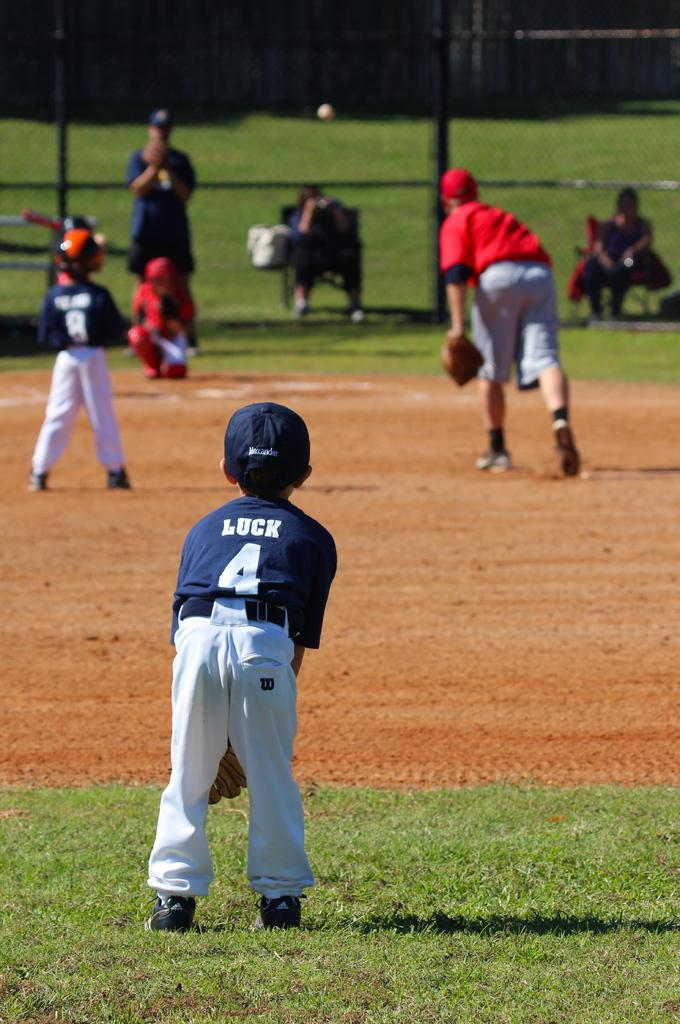<image>
Offer a succinct explanation of the picture presented. A young boy in a number 4 jersey with the name Luck on the back stands in the outfield. 